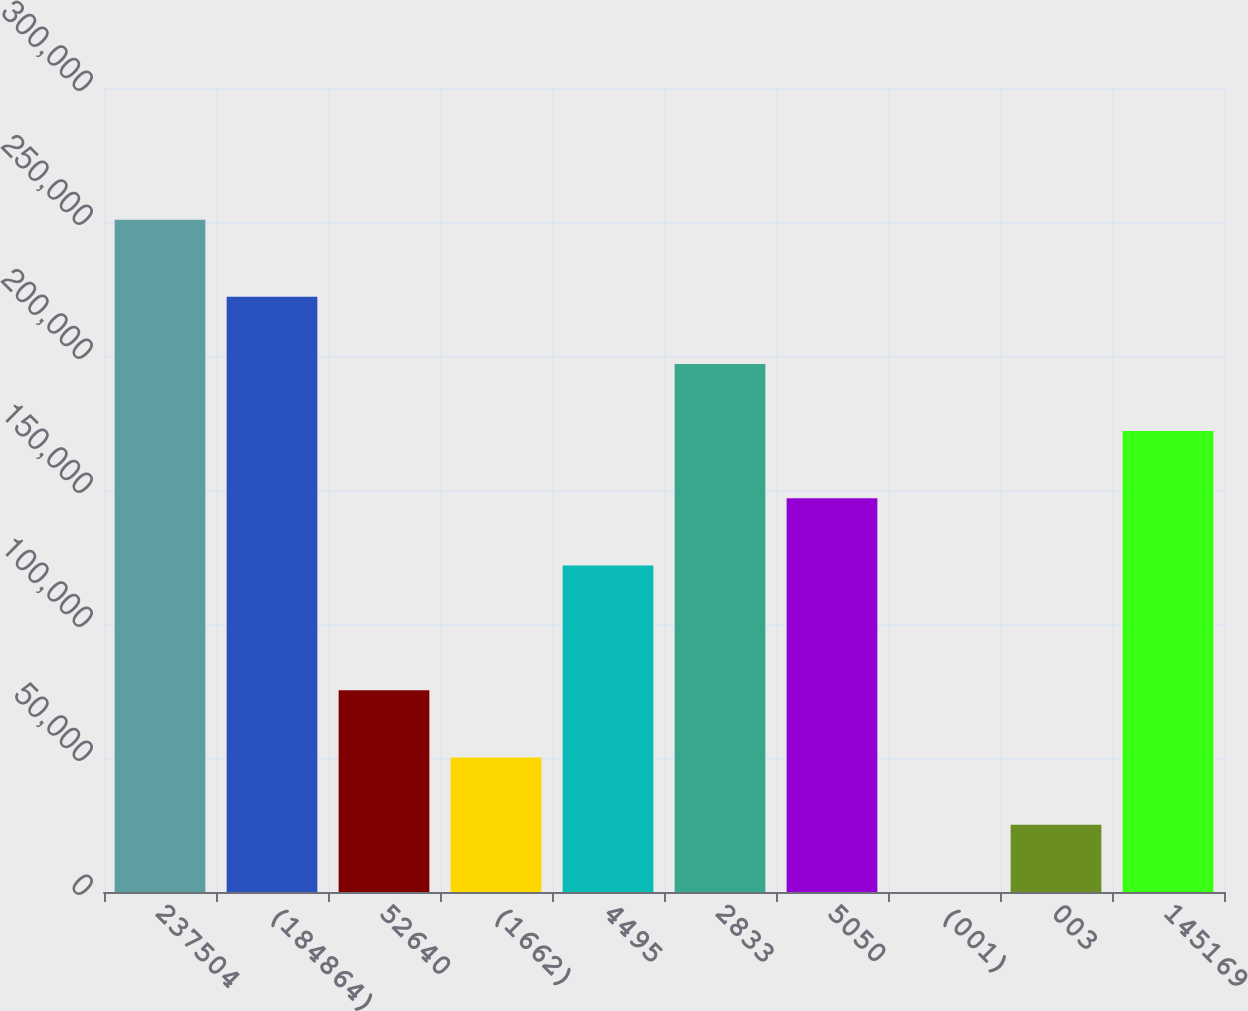Convert chart to OTSL. <chart><loc_0><loc_0><loc_500><loc_500><bar_chart><fcel>237504<fcel>(184864)<fcel>52640<fcel>(1662)<fcel>4495<fcel>2833<fcel>5050<fcel>(001)<fcel>003<fcel>145169<nl><fcel>250862<fcel>222144<fcel>75258.8<fcel>50172.6<fcel>121799<fcel>197058<fcel>146885<fcel>0.25<fcel>25086.4<fcel>171971<nl></chart> 